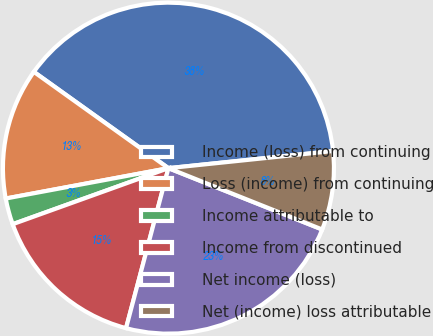Convert chart to OTSL. <chart><loc_0><loc_0><loc_500><loc_500><pie_chart><fcel>Income (loss) from continuing<fcel>Loss (income) from continuing<fcel>Income attributable to<fcel>Income from discontinued<fcel>Net income (loss)<fcel>Net (income) loss attributable<nl><fcel>38.46%<fcel>12.82%<fcel>2.56%<fcel>15.38%<fcel>23.08%<fcel>7.69%<nl></chart> 